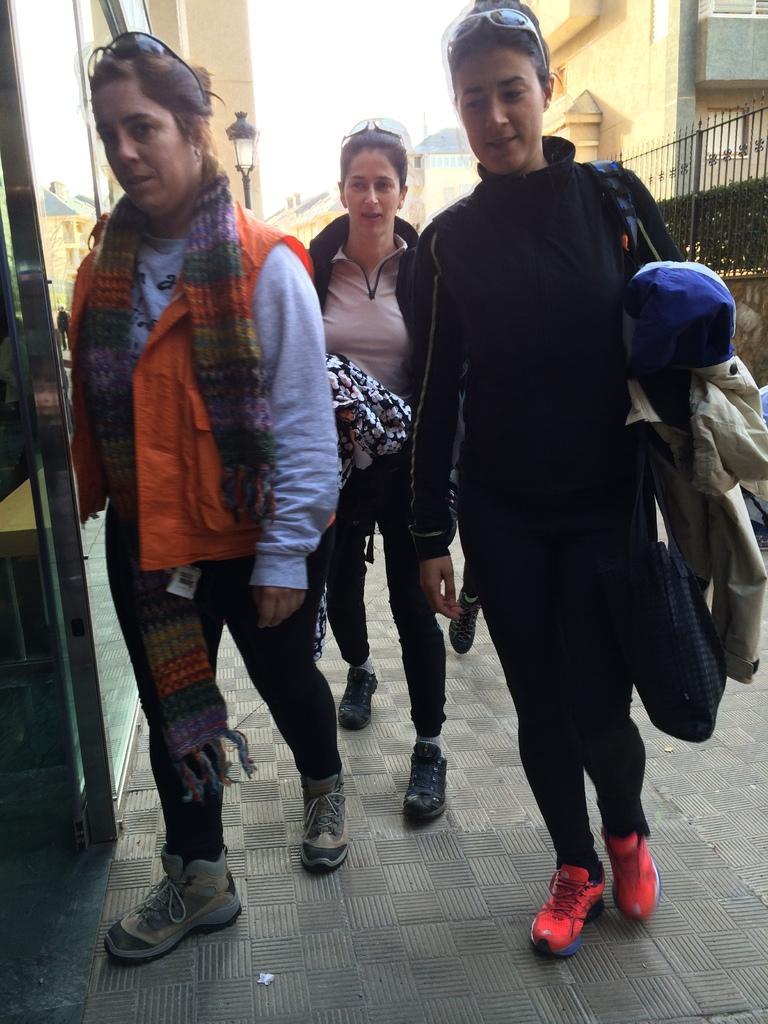Describe this image in one or two sentences. In this image we can see a group of people standing on the ground. One woman is wearing an orange jacket and goggles on her head. In the background, we can see metal barricades, group of buildings, light and the sky. 